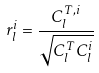Convert formula to latex. <formula><loc_0><loc_0><loc_500><loc_500>r _ { l } ^ { i } = \frac { C ^ { T , i } _ { l } } { \sqrt { C ^ { T } _ { l } C ^ { i } _ { l } } }</formula> 